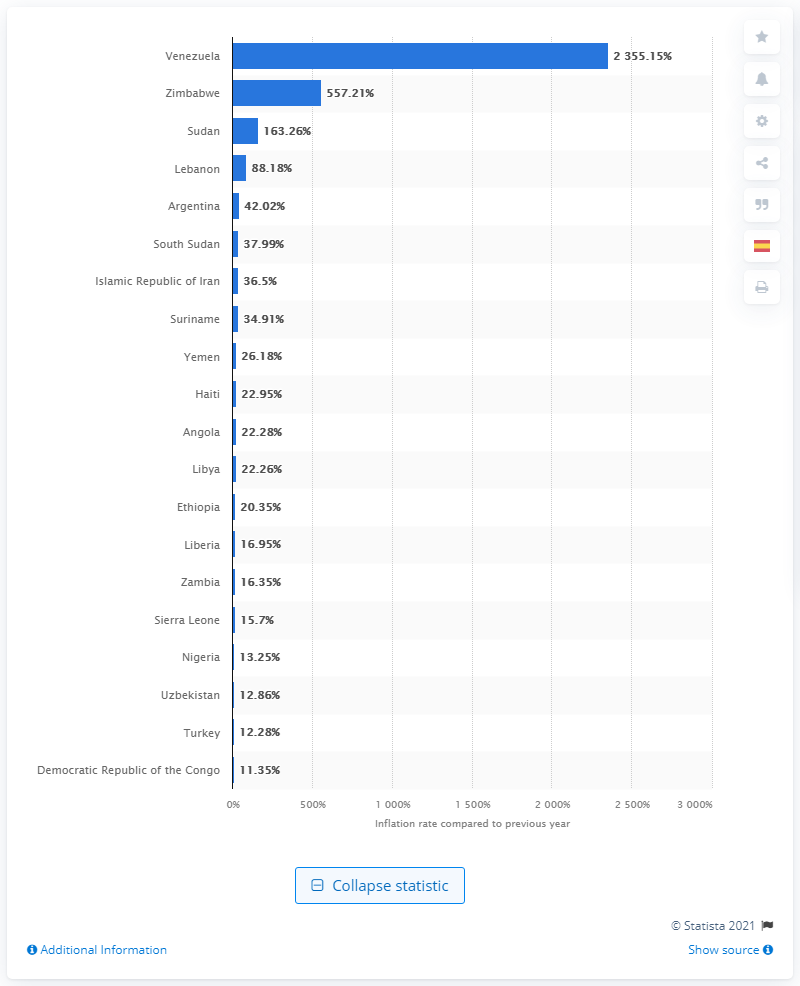Point out several critical features in this image. Sudan ranked third in 2020 with an estimated inflation rate of approximately 163.26 percent, making it one of the countries with the highest inflation rates that year. 